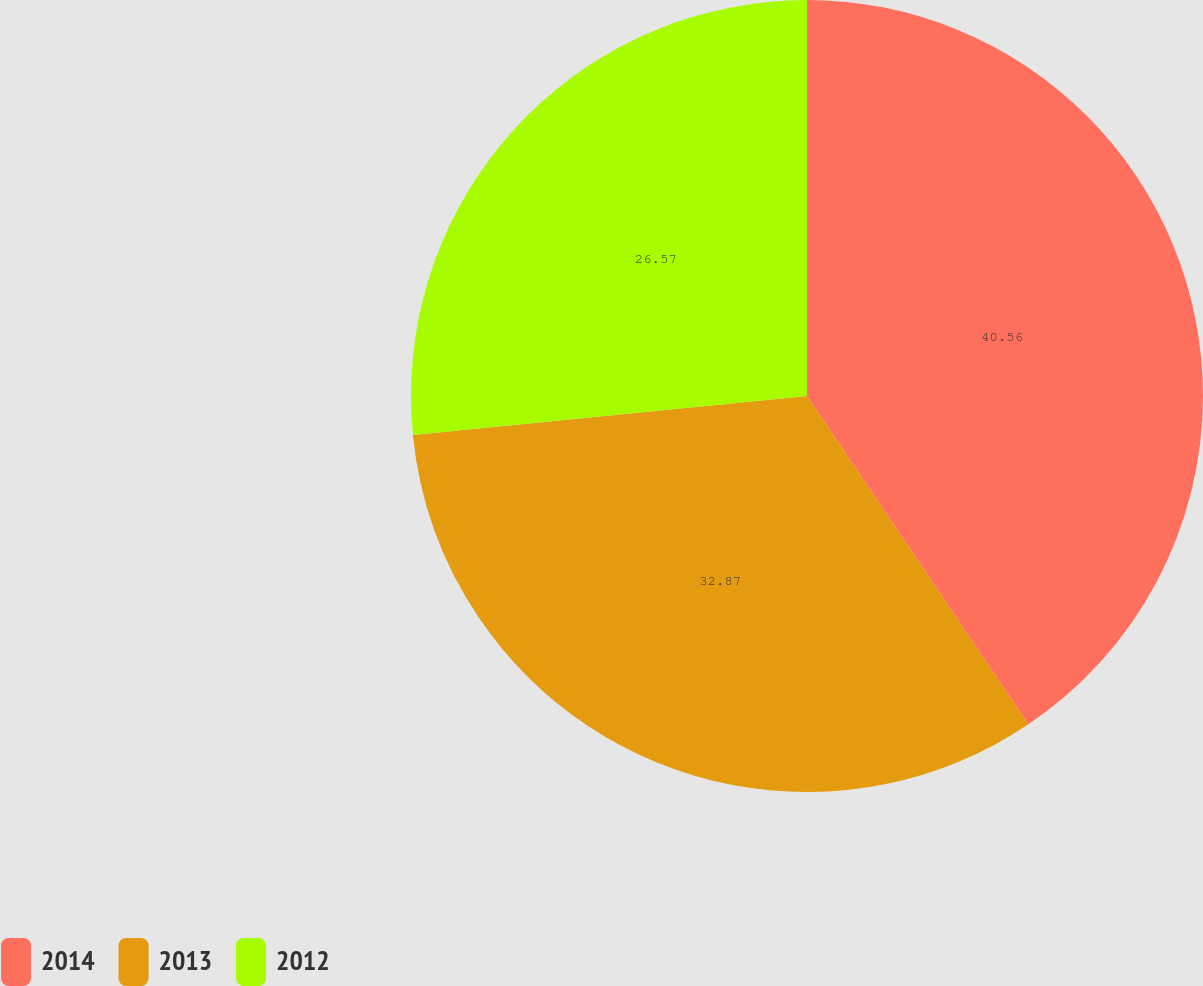Convert chart. <chart><loc_0><loc_0><loc_500><loc_500><pie_chart><fcel>2014<fcel>2013<fcel>2012<nl><fcel>40.56%<fcel>32.87%<fcel>26.57%<nl></chart> 